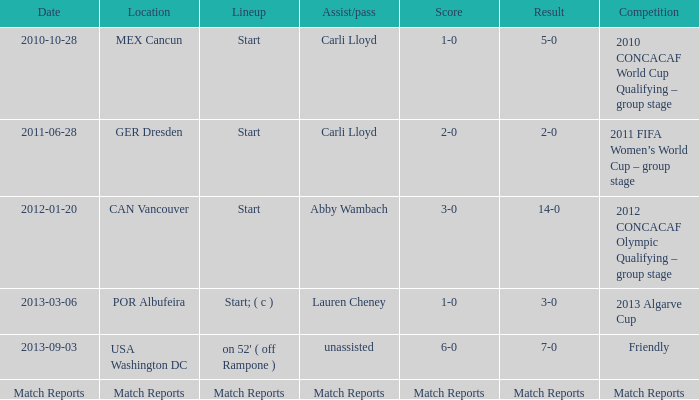Which score has a location of mex cancun? 1-0. 